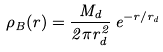Convert formula to latex. <formula><loc_0><loc_0><loc_500><loc_500>\rho _ { B } ( r ) = \frac { M _ { d } } { 2 \pi r _ { d } ^ { 2 } } \, e ^ { - r / r _ { d } }</formula> 